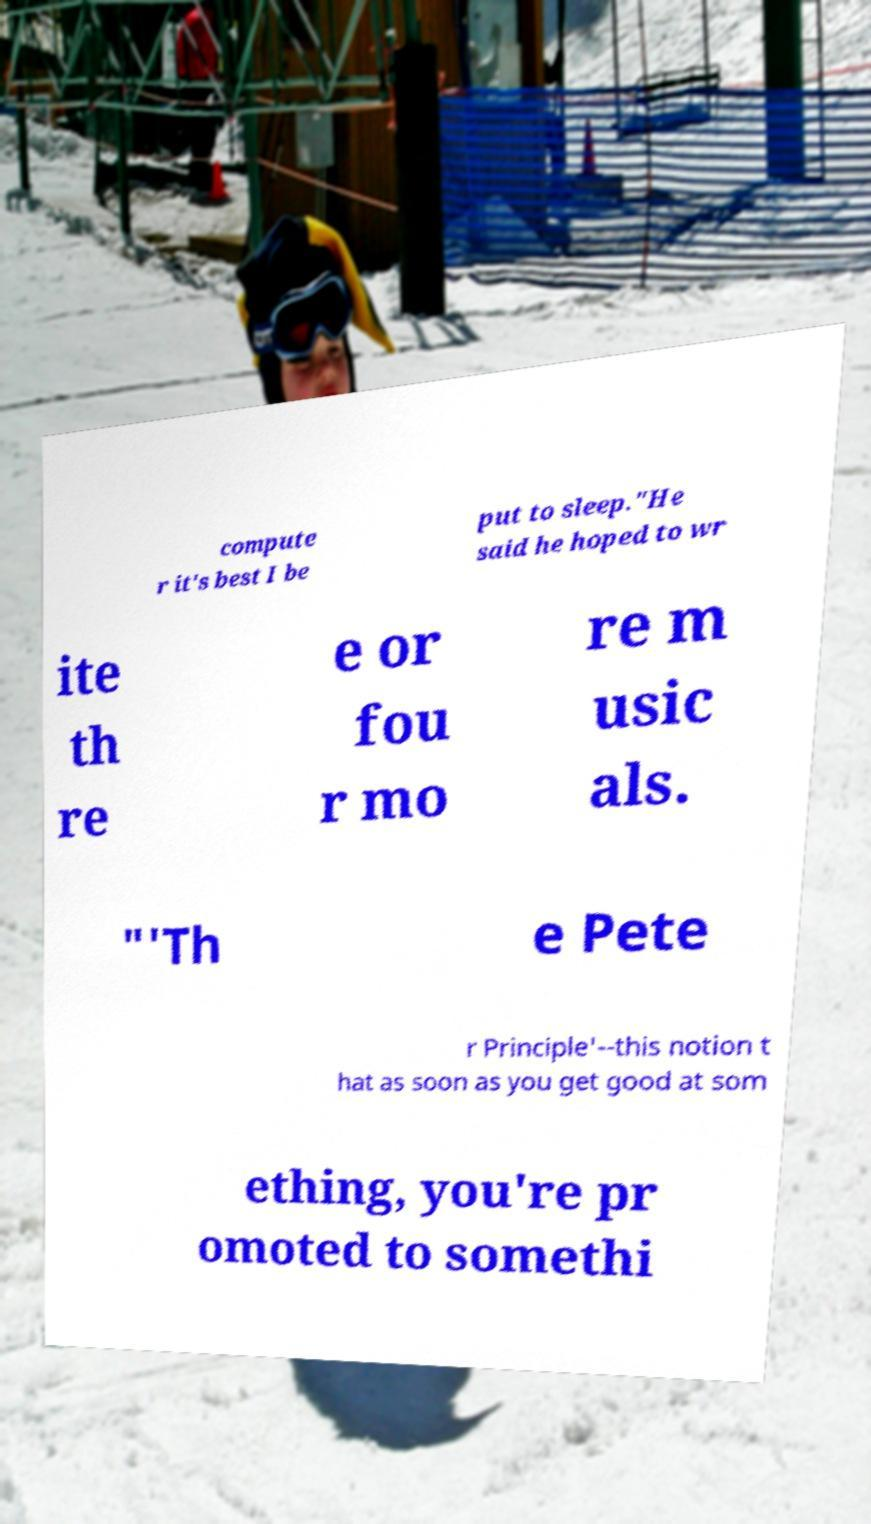There's text embedded in this image that I need extracted. Can you transcribe it verbatim? compute r it's best I be put to sleep."He said he hoped to wr ite th re e or fou r mo re m usic als. "'Th e Pete r Principle'--this notion t hat as soon as you get good at som ething, you're pr omoted to somethi 